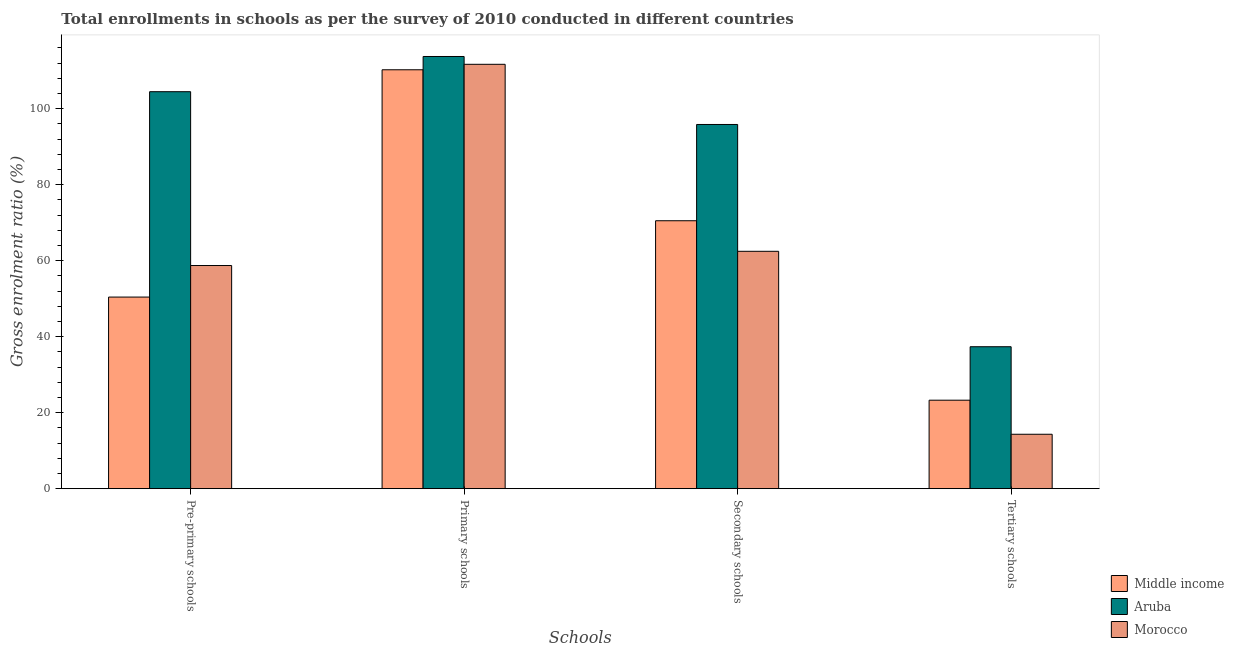How many groups of bars are there?
Provide a succinct answer. 4. Are the number of bars on each tick of the X-axis equal?
Make the answer very short. Yes. How many bars are there on the 1st tick from the left?
Ensure brevity in your answer.  3. How many bars are there on the 4th tick from the right?
Make the answer very short. 3. What is the label of the 2nd group of bars from the left?
Your response must be concise. Primary schools. What is the gross enrolment ratio in primary schools in Middle income?
Provide a succinct answer. 110.23. Across all countries, what is the maximum gross enrolment ratio in primary schools?
Offer a very short reply. 113.73. Across all countries, what is the minimum gross enrolment ratio in pre-primary schools?
Make the answer very short. 50.42. In which country was the gross enrolment ratio in tertiary schools maximum?
Your response must be concise. Aruba. In which country was the gross enrolment ratio in tertiary schools minimum?
Your response must be concise. Morocco. What is the total gross enrolment ratio in secondary schools in the graph?
Offer a very short reply. 228.8. What is the difference between the gross enrolment ratio in pre-primary schools in Morocco and that in Aruba?
Keep it short and to the point. -45.74. What is the difference between the gross enrolment ratio in pre-primary schools in Middle income and the gross enrolment ratio in secondary schools in Morocco?
Give a very brief answer. -12.04. What is the average gross enrolment ratio in primary schools per country?
Your answer should be compact. 111.88. What is the difference between the gross enrolment ratio in primary schools and gross enrolment ratio in secondary schools in Middle income?
Your response must be concise. 39.73. In how many countries, is the gross enrolment ratio in primary schools greater than 4 %?
Your answer should be compact. 3. What is the ratio of the gross enrolment ratio in tertiary schools in Morocco to that in Middle income?
Make the answer very short. 0.61. Is the gross enrolment ratio in tertiary schools in Middle income less than that in Aruba?
Your answer should be compact. Yes. Is the difference between the gross enrolment ratio in tertiary schools in Morocco and Aruba greater than the difference between the gross enrolment ratio in secondary schools in Morocco and Aruba?
Offer a terse response. Yes. What is the difference between the highest and the second highest gross enrolment ratio in primary schools?
Provide a short and direct response. 2.06. What is the difference between the highest and the lowest gross enrolment ratio in secondary schools?
Your response must be concise. 33.38. In how many countries, is the gross enrolment ratio in primary schools greater than the average gross enrolment ratio in primary schools taken over all countries?
Offer a terse response. 1. Is the sum of the gross enrolment ratio in primary schools in Aruba and Middle income greater than the maximum gross enrolment ratio in pre-primary schools across all countries?
Give a very brief answer. Yes. What does the 2nd bar from the left in Primary schools represents?
Provide a succinct answer. Aruba. What does the 1st bar from the right in Secondary schools represents?
Offer a very short reply. Morocco. Is it the case that in every country, the sum of the gross enrolment ratio in pre-primary schools and gross enrolment ratio in primary schools is greater than the gross enrolment ratio in secondary schools?
Ensure brevity in your answer.  Yes. How many bars are there?
Your answer should be compact. 12. Are all the bars in the graph horizontal?
Your response must be concise. No. Are the values on the major ticks of Y-axis written in scientific E-notation?
Provide a short and direct response. No. Does the graph contain any zero values?
Give a very brief answer. No. Does the graph contain grids?
Give a very brief answer. No. How many legend labels are there?
Offer a very short reply. 3. How are the legend labels stacked?
Keep it short and to the point. Vertical. What is the title of the graph?
Provide a succinct answer. Total enrollments in schools as per the survey of 2010 conducted in different countries. Does "Estonia" appear as one of the legend labels in the graph?
Ensure brevity in your answer.  No. What is the label or title of the X-axis?
Your answer should be compact. Schools. What is the Gross enrolment ratio (%) of Middle income in Pre-primary schools?
Provide a succinct answer. 50.42. What is the Gross enrolment ratio (%) of Aruba in Pre-primary schools?
Your response must be concise. 104.46. What is the Gross enrolment ratio (%) in Morocco in Pre-primary schools?
Make the answer very short. 58.72. What is the Gross enrolment ratio (%) in Middle income in Primary schools?
Your answer should be very brief. 110.23. What is the Gross enrolment ratio (%) in Aruba in Primary schools?
Offer a very short reply. 113.73. What is the Gross enrolment ratio (%) in Morocco in Primary schools?
Offer a terse response. 111.67. What is the Gross enrolment ratio (%) in Middle income in Secondary schools?
Your response must be concise. 70.51. What is the Gross enrolment ratio (%) of Aruba in Secondary schools?
Offer a terse response. 95.84. What is the Gross enrolment ratio (%) in Morocco in Secondary schools?
Make the answer very short. 62.46. What is the Gross enrolment ratio (%) in Middle income in Tertiary schools?
Make the answer very short. 23.28. What is the Gross enrolment ratio (%) of Aruba in Tertiary schools?
Ensure brevity in your answer.  37.35. What is the Gross enrolment ratio (%) in Morocco in Tertiary schools?
Your answer should be compact. 14.32. Across all Schools, what is the maximum Gross enrolment ratio (%) in Middle income?
Offer a very short reply. 110.23. Across all Schools, what is the maximum Gross enrolment ratio (%) of Aruba?
Provide a succinct answer. 113.73. Across all Schools, what is the maximum Gross enrolment ratio (%) in Morocco?
Offer a very short reply. 111.67. Across all Schools, what is the minimum Gross enrolment ratio (%) in Middle income?
Keep it short and to the point. 23.28. Across all Schools, what is the minimum Gross enrolment ratio (%) of Aruba?
Your answer should be compact. 37.35. Across all Schools, what is the minimum Gross enrolment ratio (%) in Morocco?
Make the answer very short. 14.32. What is the total Gross enrolment ratio (%) in Middle income in the graph?
Give a very brief answer. 254.44. What is the total Gross enrolment ratio (%) in Aruba in the graph?
Ensure brevity in your answer.  351.38. What is the total Gross enrolment ratio (%) in Morocco in the graph?
Make the answer very short. 247.17. What is the difference between the Gross enrolment ratio (%) of Middle income in Pre-primary schools and that in Primary schools?
Ensure brevity in your answer.  -59.81. What is the difference between the Gross enrolment ratio (%) in Aruba in Pre-primary schools and that in Primary schools?
Offer a terse response. -9.27. What is the difference between the Gross enrolment ratio (%) in Morocco in Pre-primary schools and that in Primary schools?
Offer a terse response. -52.95. What is the difference between the Gross enrolment ratio (%) in Middle income in Pre-primary schools and that in Secondary schools?
Your answer should be very brief. -20.08. What is the difference between the Gross enrolment ratio (%) in Aruba in Pre-primary schools and that in Secondary schools?
Your answer should be very brief. 8.63. What is the difference between the Gross enrolment ratio (%) of Morocco in Pre-primary schools and that in Secondary schools?
Provide a succinct answer. -3.74. What is the difference between the Gross enrolment ratio (%) in Middle income in Pre-primary schools and that in Tertiary schools?
Provide a succinct answer. 27.14. What is the difference between the Gross enrolment ratio (%) in Aruba in Pre-primary schools and that in Tertiary schools?
Your response must be concise. 67.11. What is the difference between the Gross enrolment ratio (%) in Morocco in Pre-primary schools and that in Tertiary schools?
Make the answer very short. 44.4. What is the difference between the Gross enrolment ratio (%) in Middle income in Primary schools and that in Secondary schools?
Your answer should be very brief. 39.73. What is the difference between the Gross enrolment ratio (%) in Aruba in Primary schools and that in Secondary schools?
Your answer should be very brief. 17.89. What is the difference between the Gross enrolment ratio (%) in Morocco in Primary schools and that in Secondary schools?
Offer a very short reply. 49.21. What is the difference between the Gross enrolment ratio (%) in Middle income in Primary schools and that in Tertiary schools?
Offer a very short reply. 86.95. What is the difference between the Gross enrolment ratio (%) of Aruba in Primary schools and that in Tertiary schools?
Your answer should be compact. 76.38. What is the difference between the Gross enrolment ratio (%) in Morocco in Primary schools and that in Tertiary schools?
Offer a terse response. 97.35. What is the difference between the Gross enrolment ratio (%) in Middle income in Secondary schools and that in Tertiary schools?
Your answer should be very brief. 47.22. What is the difference between the Gross enrolment ratio (%) in Aruba in Secondary schools and that in Tertiary schools?
Provide a succinct answer. 58.48. What is the difference between the Gross enrolment ratio (%) of Morocco in Secondary schools and that in Tertiary schools?
Your answer should be compact. 48.14. What is the difference between the Gross enrolment ratio (%) of Middle income in Pre-primary schools and the Gross enrolment ratio (%) of Aruba in Primary schools?
Keep it short and to the point. -63.31. What is the difference between the Gross enrolment ratio (%) in Middle income in Pre-primary schools and the Gross enrolment ratio (%) in Morocco in Primary schools?
Provide a succinct answer. -61.25. What is the difference between the Gross enrolment ratio (%) of Aruba in Pre-primary schools and the Gross enrolment ratio (%) of Morocco in Primary schools?
Provide a short and direct response. -7.21. What is the difference between the Gross enrolment ratio (%) in Middle income in Pre-primary schools and the Gross enrolment ratio (%) in Aruba in Secondary schools?
Provide a succinct answer. -45.42. What is the difference between the Gross enrolment ratio (%) in Middle income in Pre-primary schools and the Gross enrolment ratio (%) in Morocco in Secondary schools?
Ensure brevity in your answer.  -12.04. What is the difference between the Gross enrolment ratio (%) of Aruba in Pre-primary schools and the Gross enrolment ratio (%) of Morocco in Secondary schools?
Make the answer very short. 42. What is the difference between the Gross enrolment ratio (%) of Middle income in Pre-primary schools and the Gross enrolment ratio (%) of Aruba in Tertiary schools?
Keep it short and to the point. 13.07. What is the difference between the Gross enrolment ratio (%) of Middle income in Pre-primary schools and the Gross enrolment ratio (%) of Morocco in Tertiary schools?
Offer a terse response. 36.1. What is the difference between the Gross enrolment ratio (%) in Aruba in Pre-primary schools and the Gross enrolment ratio (%) in Morocco in Tertiary schools?
Give a very brief answer. 90.14. What is the difference between the Gross enrolment ratio (%) in Middle income in Primary schools and the Gross enrolment ratio (%) in Aruba in Secondary schools?
Ensure brevity in your answer.  14.4. What is the difference between the Gross enrolment ratio (%) in Middle income in Primary schools and the Gross enrolment ratio (%) in Morocco in Secondary schools?
Your answer should be compact. 47.77. What is the difference between the Gross enrolment ratio (%) of Aruba in Primary schools and the Gross enrolment ratio (%) of Morocco in Secondary schools?
Your answer should be compact. 51.27. What is the difference between the Gross enrolment ratio (%) in Middle income in Primary schools and the Gross enrolment ratio (%) in Aruba in Tertiary schools?
Your response must be concise. 72.88. What is the difference between the Gross enrolment ratio (%) in Middle income in Primary schools and the Gross enrolment ratio (%) in Morocco in Tertiary schools?
Your answer should be compact. 95.91. What is the difference between the Gross enrolment ratio (%) of Aruba in Primary schools and the Gross enrolment ratio (%) of Morocco in Tertiary schools?
Offer a terse response. 99.41. What is the difference between the Gross enrolment ratio (%) of Middle income in Secondary schools and the Gross enrolment ratio (%) of Aruba in Tertiary schools?
Give a very brief answer. 33.15. What is the difference between the Gross enrolment ratio (%) of Middle income in Secondary schools and the Gross enrolment ratio (%) of Morocco in Tertiary schools?
Provide a succinct answer. 56.19. What is the difference between the Gross enrolment ratio (%) of Aruba in Secondary schools and the Gross enrolment ratio (%) of Morocco in Tertiary schools?
Ensure brevity in your answer.  81.52. What is the average Gross enrolment ratio (%) of Middle income per Schools?
Keep it short and to the point. 63.61. What is the average Gross enrolment ratio (%) of Aruba per Schools?
Provide a succinct answer. 87.84. What is the average Gross enrolment ratio (%) in Morocco per Schools?
Keep it short and to the point. 61.79. What is the difference between the Gross enrolment ratio (%) of Middle income and Gross enrolment ratio (%) of Aruba in Pre-primary schools?
Your response must be concise. -54.04. What is the difference between the Gross enrolment ratio (%) in Middle income and Gross enrolment ratio (%) in Morocco in Pre-primary schools?
Your response must be concise. -8.3. What is the difference between the Gross enrolment ratio (%) in Aruba and Gross enrolment ratio (%) in Morocco in Pre-primary schools?
Make the answer very short. 45.74. What is the difference between the Gross enrolment ratio (%) in Middle income and Gross enrolment ratio (%) in Aruba in Primary schools?
Your answer should be compact. -3.5. What is the difference between the Gross enrolment ratio (%) of Middle income and Gross enrolment ratio (%) of Morocco in Primary schools?
Provide a succinct answer. -1.44. What is the difference between the Gross enrolment ratio (%) in Aruba and Gross enrolment ratio (%) in Morocco in Primary schools?
Offer a very short reply. 2.06. What is the difference between the Gross enrolment ratio (%) in Middle income and Gross enrolment ratio (%) in Aruba in Secondary schools?
Ensure brevity in your answer.  -25.33. What is the difference between the Gross enrolment ratio (%) in Middle income and Gross enrolment ratio (%) in Morocco in Secondary schools?
Your answer should be very brief. 8.04. What is the difference between the Gross enrolment ratio (%) of Aruba and Gross enrolment ratio (%) of Morocco in Secondary schools?
Your answer should be compact. 33.38. What is the difference between the Gross enrolment ratio (%) of Middle income and Gross enrolment ratio (%) of Aruba in Tertiary schools?
Offer a very short reply. -14.07. What is the difference between the Gross enrolment ratio (%) of Middle income and Gross enrolment ratio (%) of Morocco in Tertiary schools?
Offer a very short reply. 8.97. What is the difference between the Gross enrolment ratio (%) in Aruba and Gross enrolment ratio (%) in Morocco in Tertiary schools?
Offer a very short reply. 23.03. What is the ratio of the Gross enrolment ratio (%) in Middle income in Pre-primary schools to that in Primary schools?
Make the answer very short. 0.46. What is the ratio of the Gross enrolment ratio (%) of Aruba in Pre-primary schools to that in Primary schools?
Your response must be concise. 0.92. What is the ratio of the Gross enrolment ratio (%) in Morocco in Pre-primary schools to that in Primary schools?
Your answer should be compact. 0.53. What is the ratio of the Gross enrolment ratio (%) of Middle income in Pre-primary schools to that in Secondary schools?
Offer a very short reply. 0.72. What is the ratio of the Gross enrolment ratio (%) of Aruba in Pre-primary schools to that in Secondary schools?
Offer a very short reply. 1.09. What is the ratio of the Gross enrolment ratio (%) of Morocco in Pre-primary schools to that in Secondary schools?
Your answer should be very brief. 0.94. What is the ratio of the Gross enrolment ratio (%) in Middle income in Pre-primary schools to that in Tertiary schools?
Make the answer very short. 2.17. What is the ratio of the Gross enrolment ratio (%) in Aruba in Pre-primary schools to that in Tertiary schools?
Offer a terse response. 2.8. What is the ratio of the Gross enrolment ratio (%) of Morocco in Pre-primary schools to that in Tertiary schools?
Offer a terse response. 4.1. What is the ratio of the Gross enrolment ratio (%) in Middle income in Primary schools to that in Secondary schools?
Offer a very short reply. 1.56. What is the ratio of the Gross enrolment ratio (%) of Aruba in Primary schools to that in Secondary schools?
Make the answer very short. 1.19. What is the ratio of the Gross enrolment ratio (%) in Morocco in Primary schools to that in Secondary schools?
Provide a succinct answer. 1.79. What is the ratio of the Gross enrolment ratio (%) of Middle income in Primary schools to that in Tertiary schools?
Ensure brevity in your answer.  4.73. What is the ratio of the Gross enrolment ratio (%) in Aruba in Primary schools to that in Tertiary schools?
Provide a succinct answer. 3.04. What is the ratio of the Gross enrolment ratio (%) in Morocco in Primary schools to that in Tertiary schools?
Your answer should be compact. 7.8. What is the ratio of the Gross enrolment ratio (%) in Middle income in Secondary schools to that in Tertiary schools?
Offer a terse response. 3.03. What is the ratio of the Gross enrolment ratio (%) of Aruba in Secondary schools to that in Tertiary schools?
Offer a very short reply. 2.57. What is the ratio of the Gross enrolment ratio (%) in Morocco in Secondary schools to that in Tertiary schools?
Your response must be concise. 4.36. What is the difference between the highest and the second highest Gross enrolment ratio (%) of Middle income?
Your answer should be compact. 39.73. What is the difference between the highest and the second highest Gross enrolment ratio (%) of Aruba?
Give a very brief answer. 9.27. What is the difference between the highest and the second highest Gross enrolment ratio (%) of Morocco?
Your answer should be very brief. 49.21. What is the difference between the highest and the lowest Gross enrolment ratio (%) in Middle income?
Provide a succinct answer. 86.95. What is the difference between the highest and the lowest Gross enrolment ratio (%) of Aruba?
Offer a terse response. 76.38. What is the difference between the highest and the lowest Gross enrolment ratio (%) in Morocco?
Provide a short and direct response. 97.35. 